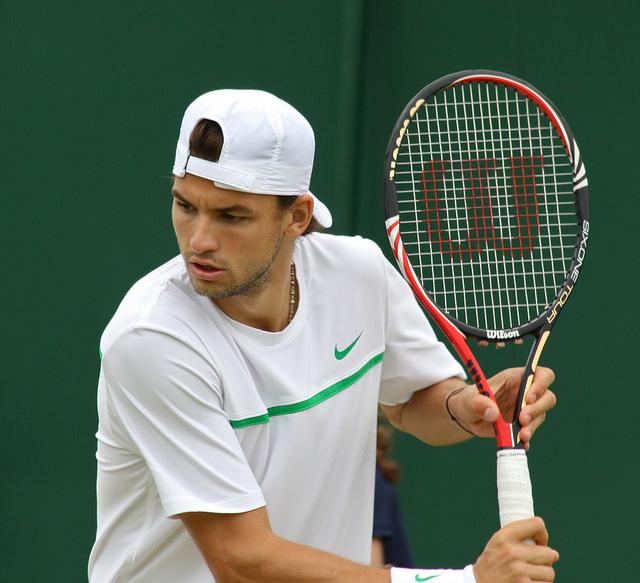What brand of shirt are they wearing?
Keep it brief. Nike. What brand is the racket?
Write a very short answer. Wilson. What is this person holding?
Concise answer only. Tennis racket. 